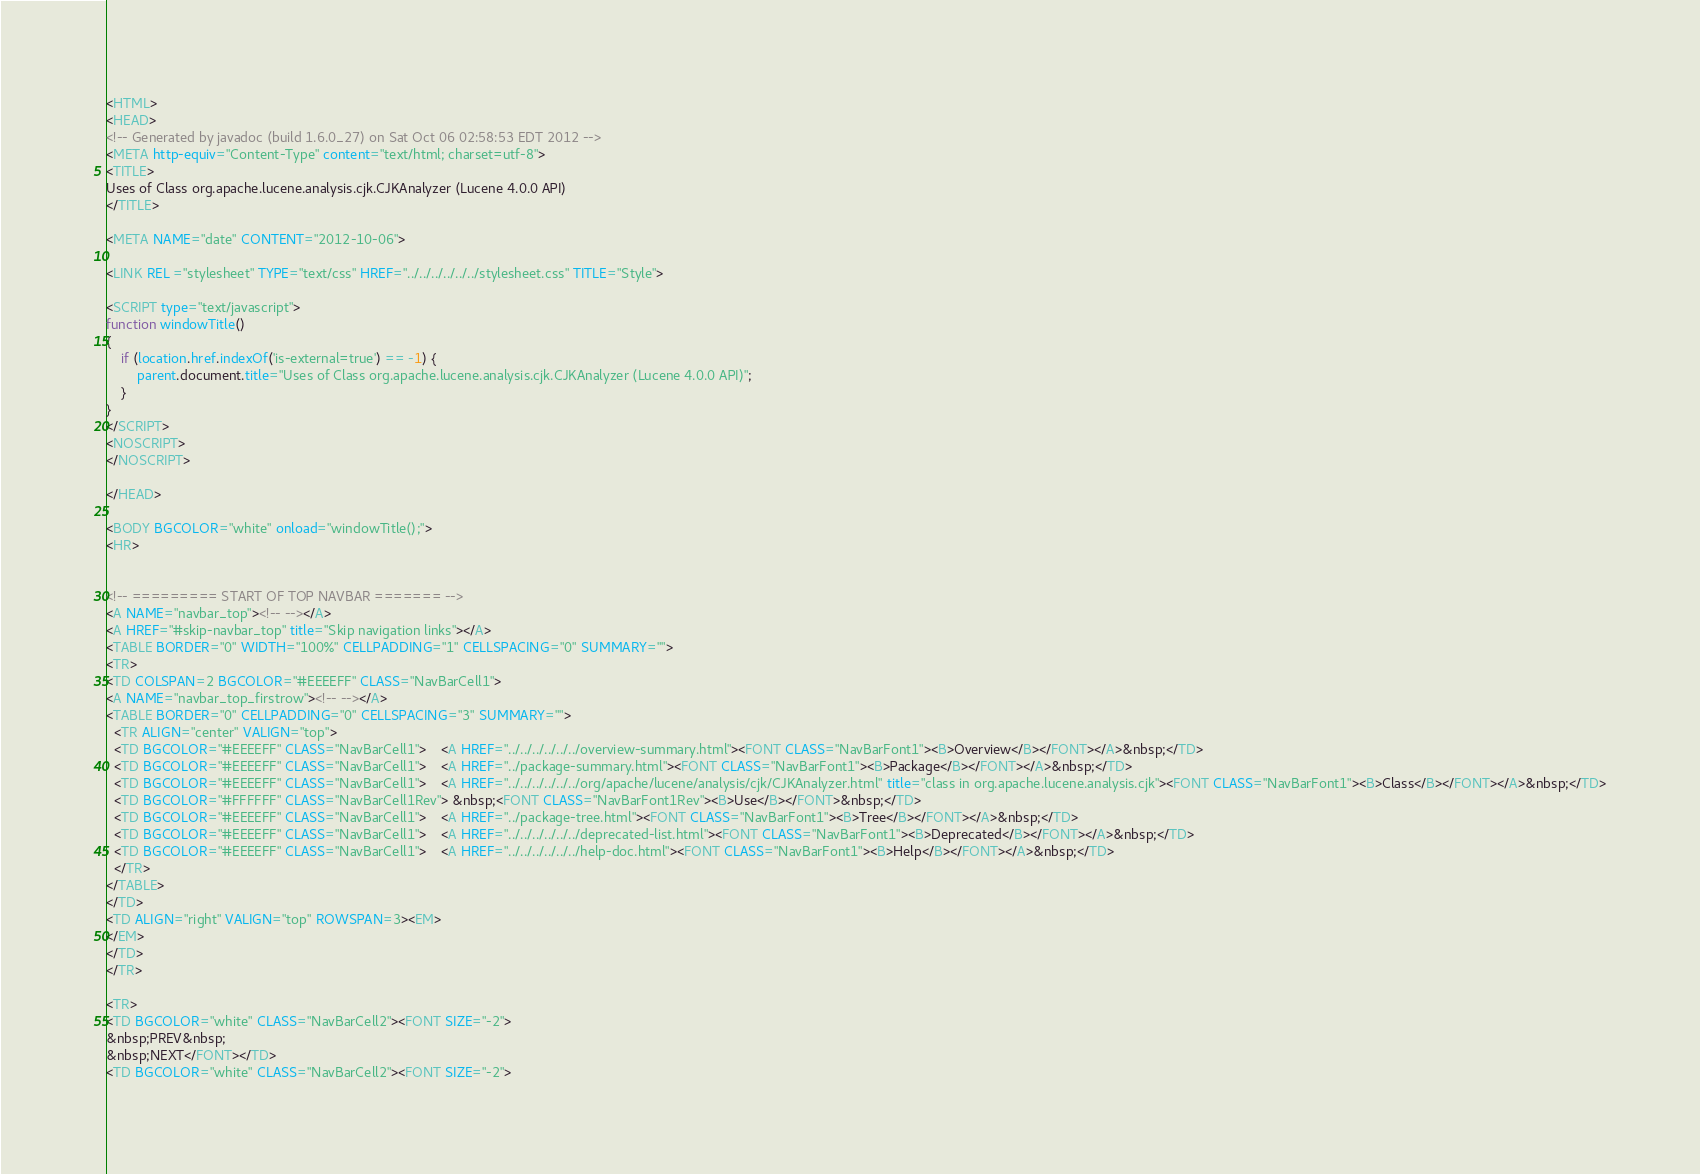<code> <loc_0><loc_0><loc_500><loc_500><_HTML_><HTML>
<HEAD>
<!-- Generated by javadoc (build 1.6.0_27) on Sat Oct 06 02:58:53 EDT 2012 -->
<META http-equiv="Content-Type" content="text/html; charset=utf-8">
<TITLE>
Uses of Class org.apache.lucene.analysis.cjk.CJKAnalyzer (Lucene 4.0.0 API)
</TITLE>

<META NAME="date" CONTENT="2012-10-06">

<LINK REL ="stylesheet" TYPE="text/css" HREF="../../../../../../stylesheet.css" TITLE="Style">

<SCRIPT type="text/javascript">
function windowTitle()
{
    if (location.href.indexOf('is-external=true') == -1) {
        parent.document.title="Uses of Class org.apache.lucene.analysis.cjk.CJKAnalyzer (Lucene 4.0.0 API)";
    }
}
</SCRIPT>
<NOSCRIPT>
</NOSCRIPT>

</HEAD>

<BODY BGCOLOR="white" onload="windowTitle();">
<HR>


<!-- ========= START OF TOP NAVBAR ======= -->
<A NAME="navbar_top"><!-- --></A>
<A HREF="#skip-navbar_top" title="Skip navigation links"></A>
<TABLE BORDER="0" WIDTH="100%" CELLPADDING="1" CELLSPACING="0" SUMMARY="">
<TR>
<TD COLSPAN=2 BGCOLOR="#EEEEFF" CLASS="NavBarCell1">
<A NAME="navbar_top_firstrow"><!-- --></A>
<TABLE BORDER="0" CELLPADDING="0" CELLSPACING="3" SUMMARY="">
  <TR ALIGN="center" VALIGN="top">
  <TD BGCOLOR="#EEEEFF" CLASS="NavBarCell1">    <A HREF="../../../../../../overview-summary.html"><FONT CLASS="NavBarFont1"><B>Overview</B></FONT></A>&nbsp;</TD>
  <TD BGCOLOR="#EEEEFF" CLASS="NavBarCell1">    <A HREF="../package-summary.html"><FONT CLASS="NavBarFont1"><B>Package</B></FONT></A>&nbsp;</TD>
  <TD BGCOLOR="#EEEEFF" CLASS="NavBarCell1">    <A HREF="../../../../../../org/apache/lucene/analysis/cjk/CJKAnalyzer.html" title="class in org.apache.lucene.analysis.cjk"><FONT CLASS="NavBarFont1"><B>Class</B></FONT></A>&nbsp;</TD>
  <TD BGCOLOR="#FFFFFF" CLASS="NavBarCell1Rev"> &nbsp;<FONT CLASS="NavBarFont1Rev"><B>Use</B></FONT>&nbsp;</TD>
  <TD BGCOLOR="#EEEEFF" CLASS="NavBarCell1">    <A HREF="../package-tree.html"><FONT CLASS="NavBarFont1"><B>Tree</B></FONT></A>&nbsp;</TD>
  <TD BGCOLOR="#EEEEFF" CLASS="NavBarCell1">    <A HREF="../../../../../../deprecated-list.html"><FONT CLASS="NavBarFont1"><B>Deprecated</B></FONT></A>&nbsp;</TD>
  <TD BGCOLOR="#EEEEFF" CLASS="NavBarCell1">    <A HREF="../../../../../../help-doc.html"><FONT CLASS="NavBarFont1"><B>Help</B></FONT></A>&nbsp;</TD>
  </TR>
</TABLE>
</TD>
<TD ALIGN="right" VALIGN="top" ROWSPAN=3><EM>
</EM>
</TD>
</TR>

<TR>
<TD BGCOLOR="white" CLASS="NavBarCell2"><FONT SIZE="-2">
&nbsp;PREV&nbsp;
&nbsp;NEXT</FONT></TD>
<TD BGCOLOR="white" CLASS="NavBarCell2"><FONT SIZE="-2"></code> 